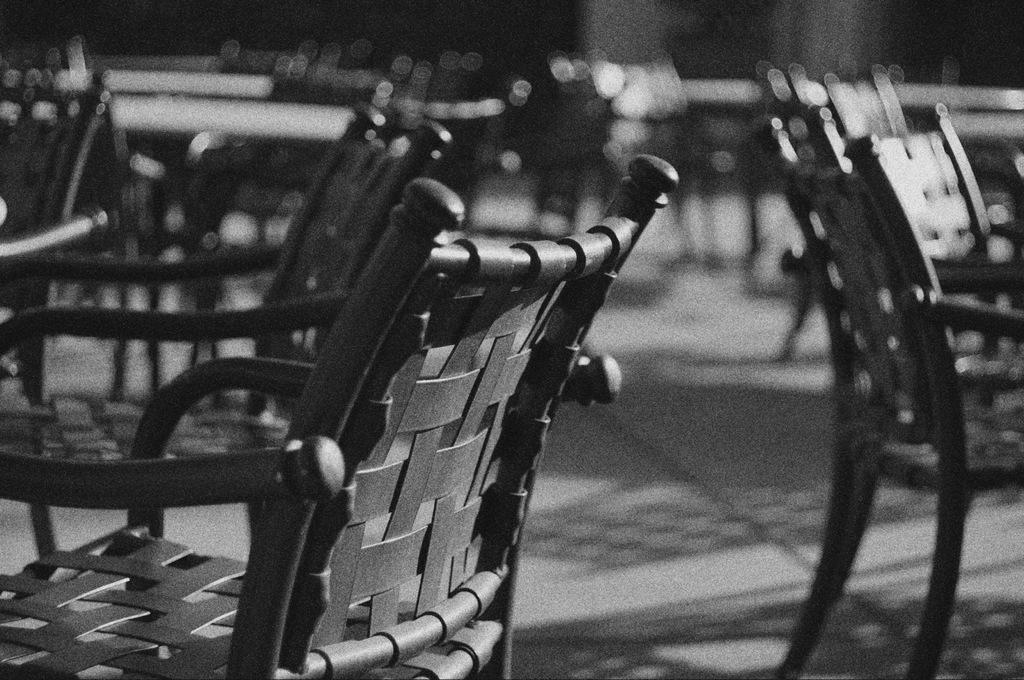What is the color scheme of the image? The image is black and white. What type of furniture can be seen in the image? There are chairs in the image. What can be seen in the image that might indicate a path or direction? There is a path visible in the image. What type of bucket is being used to create the effect in the image? There is no bucket or any effect present in the image; it is a black and white image with chairs and a path. 